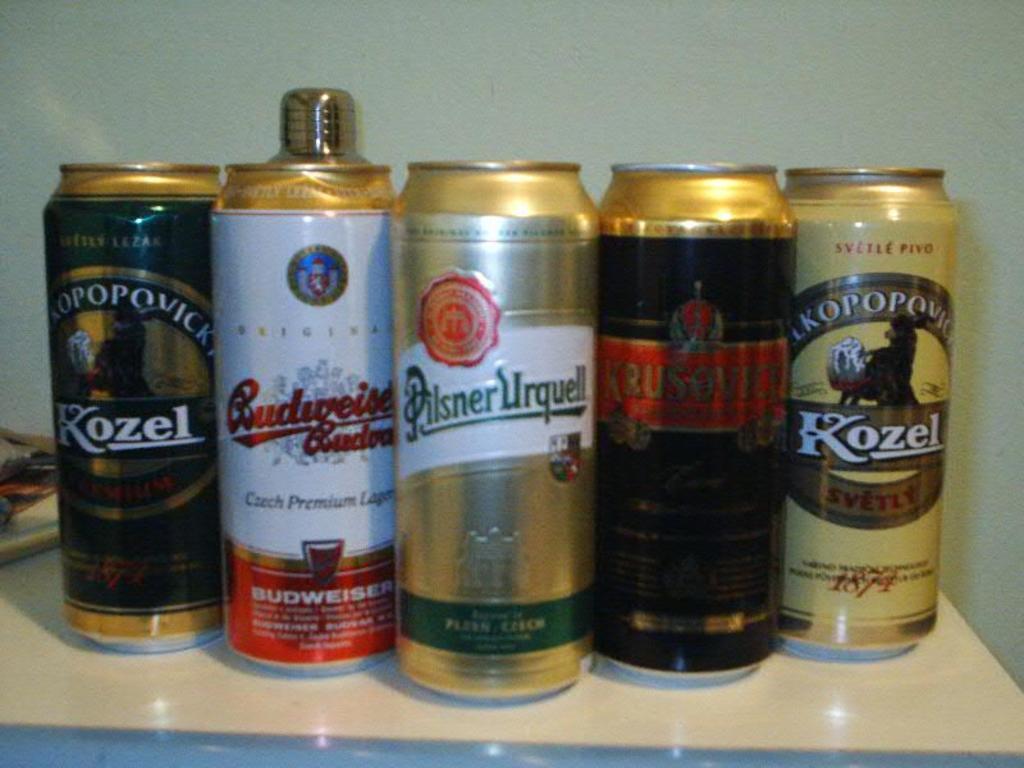What is the brand of the middle can?
Offer a very short reply. Pilsner urquell. 